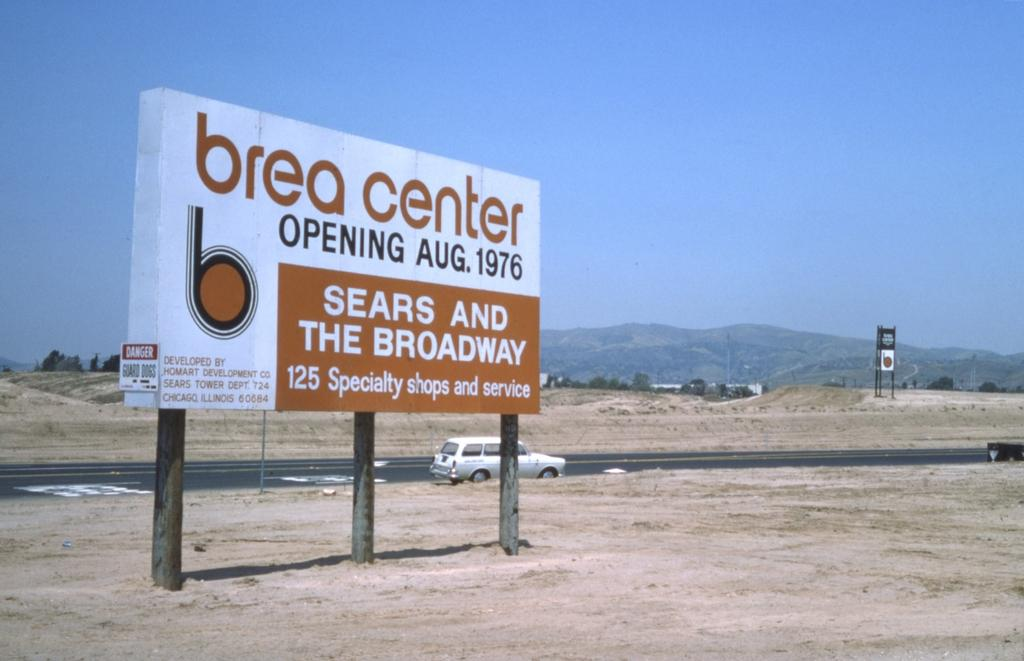What is the main object in the foreground of the image? There is a hoarding in the image. What can be found on the hoarding? There is text on the hoarding. What can be seen behind the hoarding? There is a car on the road behind the hoarding. What type of natural scenery is visible in the background of the image? There are trees and hills visible in the background of the image. What flavor of tramp can be seen in the image? There is no tramp present in the image, and therefore no flavor can be associated with it. 